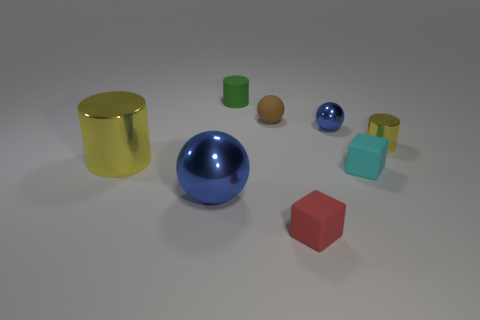There is a metallic cylinder that is to the right of the large cylinder; what number of small green matte things are behind it?
Provide a short and direct response. 1. What size is the thing that is both in front of the small cyan cube and behind the small red thing?
Ensure brevity in your answer.  Large. What is the cylinder on the right side of the red object made of?
Make the answer very short. Metal. Are there any other small things of the same shape as the tiny cyan thing?
Give a very brief answer. Yes. What number of yellow objects are the same shape as the small green rubber thing?
Offer a terse response. 2. There is a blue shiny thing that is on the left side of the small rubber cylinder; is it the same size as the blue shiny object behind the tiny yellow cylinder?
Give a very brief answer. No. The blue thing to the left of the small matte sphere that is on the right side of the small green object is what shape?
Keep it short and to the point. Sphere. Is the number of cyan objects that are behind the green matte thing the same as the number of big cyan shiny cylinders?
Your answer should be compact. Yes. What material is the cube to the left of the cube that is behind the big blue sphere that is left of the small yellow metal thing?
Provide a succinct answer. Rubber. Is there a yellow thing of the same size as the green thing?
Keep it short and to the point. Yes. 